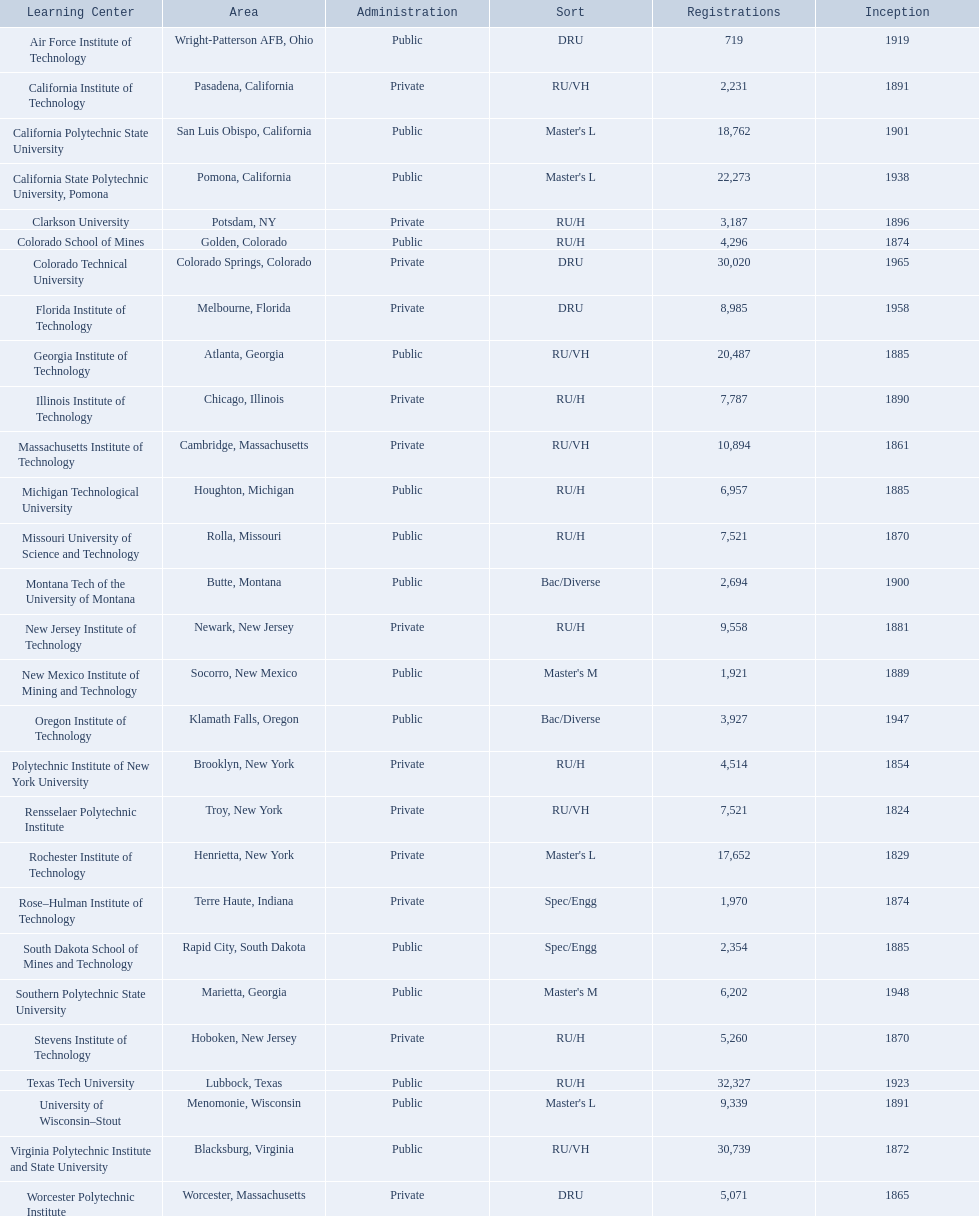What are the listed enrollment numbers of us universities? 719, 2,231, 18,762, 22,273, 3,187, 4,296, 30,020, 8,985, 20,487, 7,787, 10,894, 6,957, 7,521, 2,694, 9,558, 1,921, 3,927, 4,514, 7,521, 17,652, 1,970, 2,354, 6,202, 5,260, 32,327, 9,339, 30,739, 5,071. Of these, which has the highest value? 32,327. What are the listed names of us universities? Air Force Institute of Technology, California Institute of Technology, California Polytechnic State University, California State Polytechnic University, Pomona, Clarkson University, Colorado School of Mines, Colorado Technical University, Florida Institute of Technology, Georgia Institute of Technology, Illinois Institute of Technology, Massachusetts Institute of Technology, Michigan Technological University, Missouri University of Science and Technology, Montana Tech of the University of Montana, New Jersey Institute of Technology, New Mexico Institute of Mining and Technology, Oregon Institute of Technology, Polytechnic Institute of New York University, Rensselaer Polytechnic Institute, Rochester Institute of Technology, Rose–Hulman Institute of Technology, South Dakota School of Mines and Technology, Southern Polytechnic State University, Stevens Institute of Technology, Texas Tech University, University of Wisconsin–Stout, Virginia Polytechnic Institute and State University, Worcester Polytechnic Institute. Which of these correspond to the previously listed highest enrollment value? Texas Tech University. 